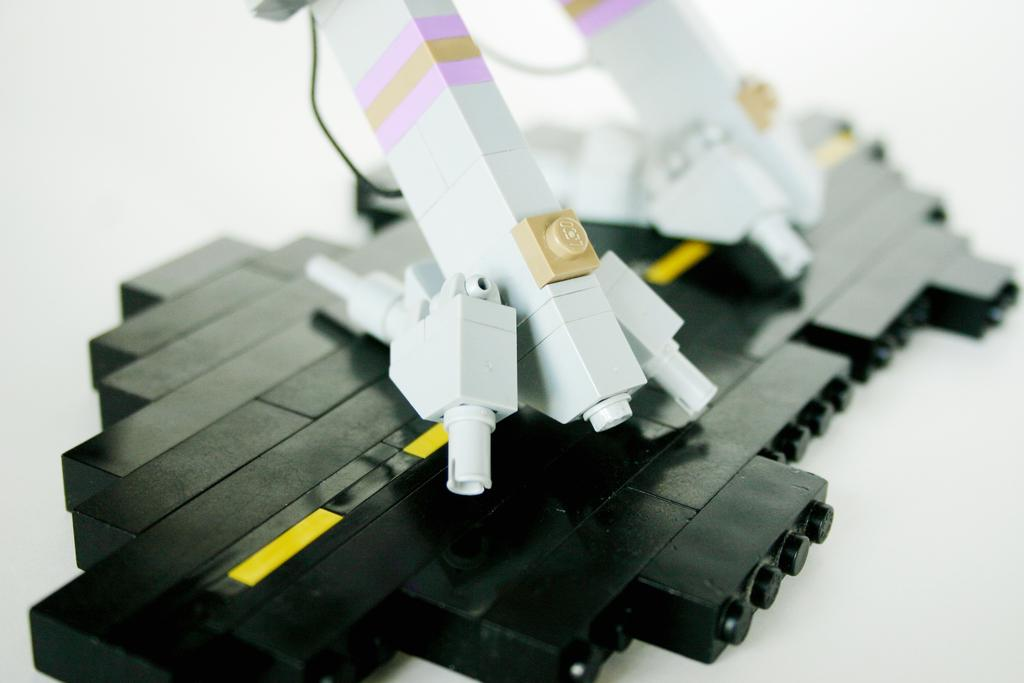What colors are present in the objects in the image? There are black and white objects in the image. Can you tell me how many berries are present in the image? There is no berry present in the image. What type of thumb can be seen interacting with the objects in the image? There is no thumb present in the image; it only features black and white objects. 